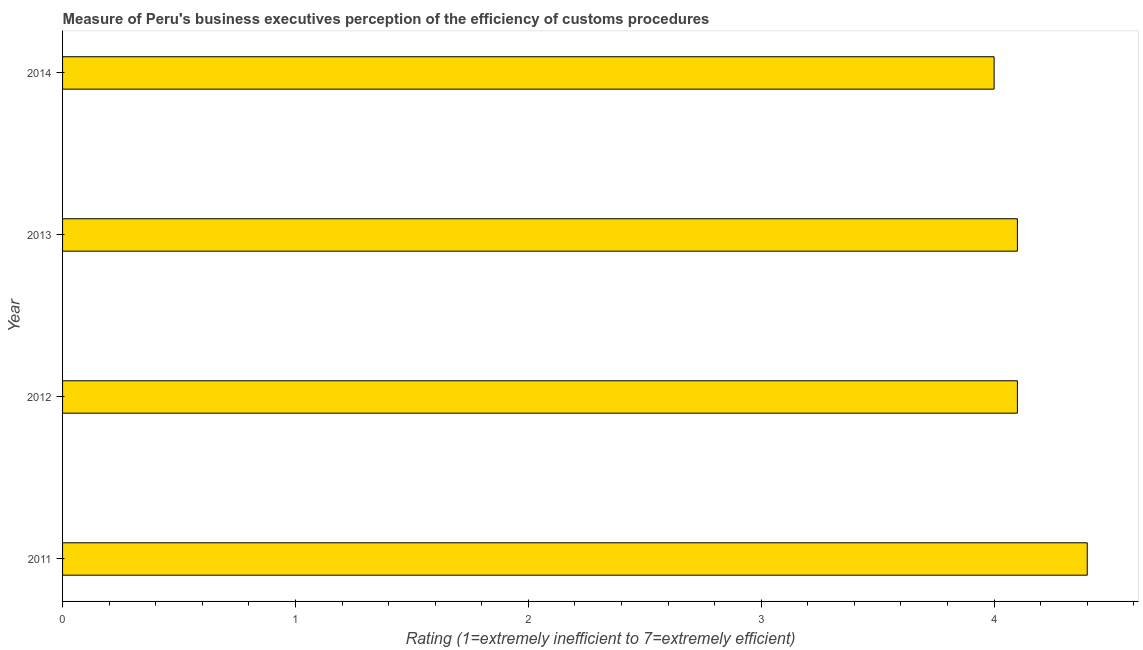Does the graph contain grids?
Your response must be concise. No. What is the title of the graph?
Your response must be concise. Measure of Peru's business executives perception of the efficiency of customs procedures. What is the label or title of the X-axis?
Ensure brevity in your answer.  Rating (1=extremely inefficient to 7=extremely efficient). What is the label or title of the Y-axis?
Offer a very short reply. Year. Across all years, what is the maximum rating measuring burden of customs procedure?
Provide a short and direct response. 4.4. In which year was the rating measuring burden of customs procedure maximum?
Make the answer very short. 2011. In which year was the rating measuring burden of customs procedure minimum?
Offer a very short reply. 2014. What is the sum of the rating measuring burden of customs procedure?
Keep it short and to the point. 16.6. What is the difference between the rating measuring burden of customs procedure in 2012 and 2014?
Your answer should be very brief. 0.1. What is the average rating measuring burden of customs procedure per year?
Ensure brevity in your answer.  4.15. What is the median rating measuring burden of customs procedure?
Your answer should be compact. 4.1. What is the ratio of the rating measuring burden of customs procedure in 2012 to that in 2013?
Give a very brief answer. 1. What is the difference between the highest and the second highest rating measuring burden of customs procedure?
Your answer should be very brief. 0.3. Is the sum of the rating measuring burden of customs procedure in 2011 and 2014 greater than the maximum rating measuring burden of customs procedure across all years?
Your response must be concise. Yes. How many bars are there?
Make the answer very short. 4. Are all the bars in the graph horizontal?
Ensure brevity in your answer.  Yes. How many years are there in the graph?
Provide a short and direct response. 4. Are the values on the major ticks of X-axis written in scientific E-notation?
Keep it short and to the point. No. What is the Rating (1=extremely inefficient to 7=extremely efficient) in 2012?
Offer a terse response. 4.1. What is the Rating (1=extremely inefficient to 7=extremely efficient) in 2013?
Keep it short and to the point. 4.1. What is the Rating (1=extremely inefficient to 7=extremely efficient) in 2014?
Offer a very short reply. 4. What is the difference between the Rating (1=extremely inefficient to 7=extremely efficient) in 2011 and 2012?
Make the answer very short. 0.3. What is the difference between the Rating (1=extremely inefficient to 7=extremely efficient) in 2012 and 2014?
Provide a succinct answer. 0.1. What is the difference between the Rating (1=extremely inefficient to 7=extremely efficient) in 2013 and 2014?
Your answer should be very brief. 0.1. What is the ratio of the Rating (1=extremely inefficient to 7=extremely efficient) in 2011 to that in 2012?
Keep it short and to the point. 1.07. What is the ratio of the Rating (1=extremely inefficient to 7=extremely efficient) in 2011 to that in 2013?
Keep it short and to the point. 1.07. What is the ratio of the Rating (1=extremely inefficient to 7=extremely efficient) in 2012 to that in 2013?
Give a very brief answer. 1. 